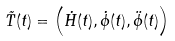Convert formula to latex. <formula><loc_0><loc_0><loc_500><loc_500>\vec { T } ( t ) = \left ( \dot { H } ( t ) , \dot { \phi } ( t ) , \ddot { \phi } ( t ) \right )</formula> 